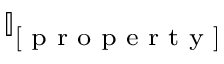Convert formula to latex. <formula><loc_0><loc_0><loc_500><loc_500>\mathbb { I } _ { [ p r o p e r t y ] }</formula> 